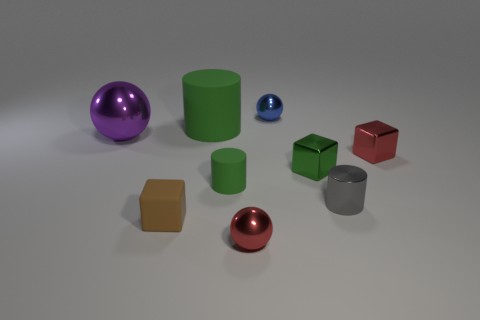Add 1 small metallic blocks. How many objects exist? 10 Subtract all spheres. How many objects are left? 6 Add 9 small red balls. How many small red balls exist? 10 Subtract 0 cyan balls. How many objects are left? 9 Subtract all small blue shiny spheres. Subtract all large matte cylinders. How many objects are left? 7 Add 5 big objects. How many big objects are left? 7 